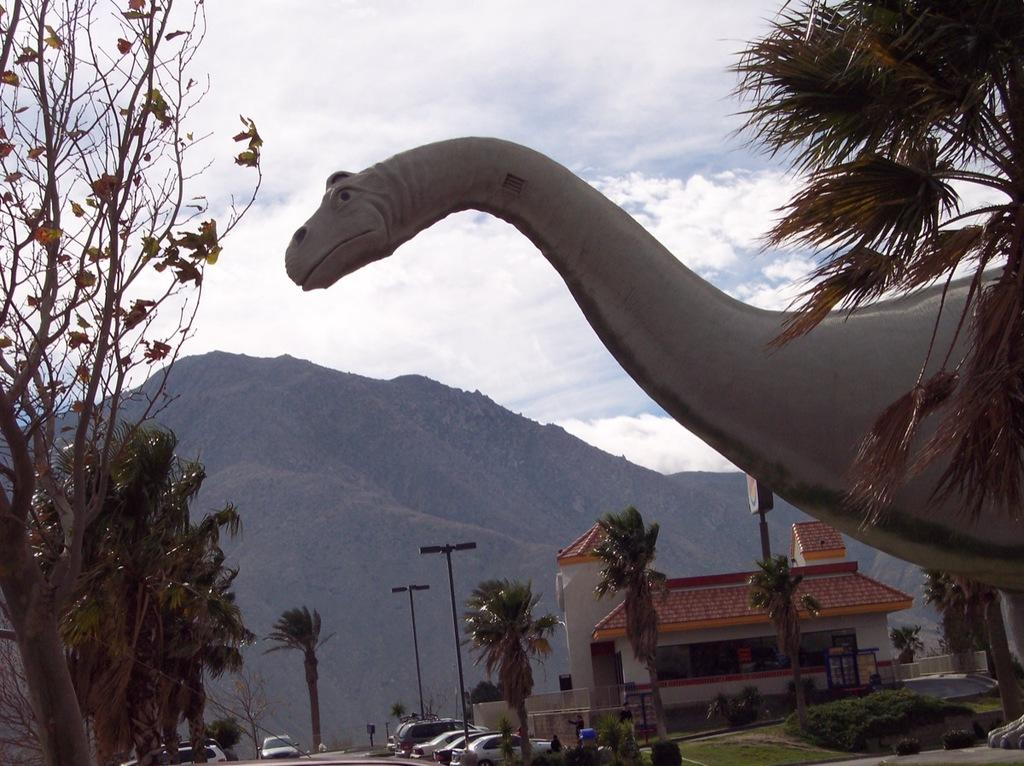What is the main subject of the image? There is a big sculpture of dinosaurs in the image. What can be seen behind the sculpture? There is a building behind the sculpture. What is parked in front of the building? There are cars parked in front of the building. What type of natural features are visible in the image? There are mountains and trees visible in the image. What type of lace can be seen on the building in the image? There is no lace visible on the building in the image. What type of vacation is being depicted in the image? The image does not depict a vacation; it features a sculpture of dinosaurs, a building, cars, mountains, and trees. 